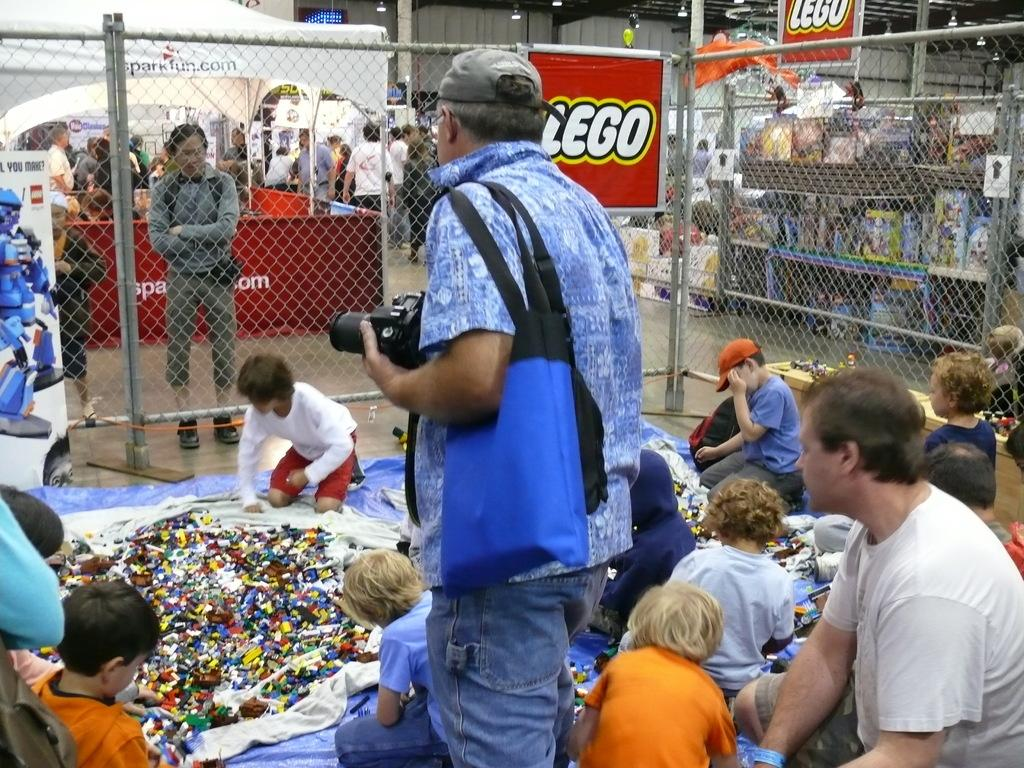How many persons can be seen in the image? There are persons in the image. What object is used for capturing images in the image? There is a camera in the image. What item might be used for carrying personal belongings in the image? There is a bag in the image. What can be seen in the background of the image? There is a fence, name boards, lights, persons, a wall, and other objects in the background of the image. What type of quarter is being used for reading in the image? There is no quarter or reading activity present in the image. Is there a crook visible in the image? There is no crook present in the image. 